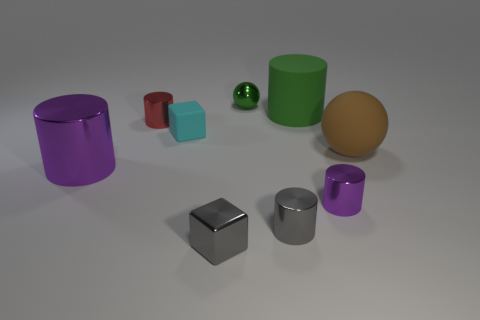What shape is the purple object to the right of the purple metal cylinder that is to the left of the small purple cylinder? The purple object to the right of the purple metal cylinder, which is located to the left of the small purple cylinder, is also a cylinder. It is a larger cylinder with a shiny surface, reflecting the environment and having a distinct metallic sheen, indicative of a possibly metallic material. 